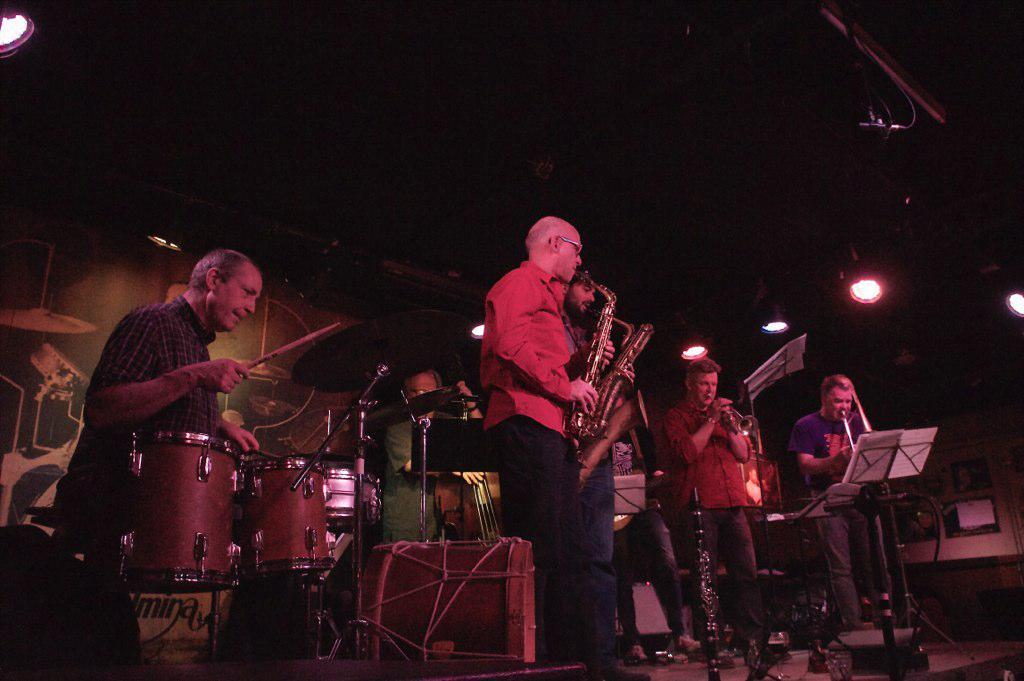Describe this image in one or two sentences. In this picture there are group of people, those who are singing on the stage there is a person who is standing at the left side of the image he is playing the drums and the other people at the right side of the image, they are singing, there are spotlights around the area of the image. 